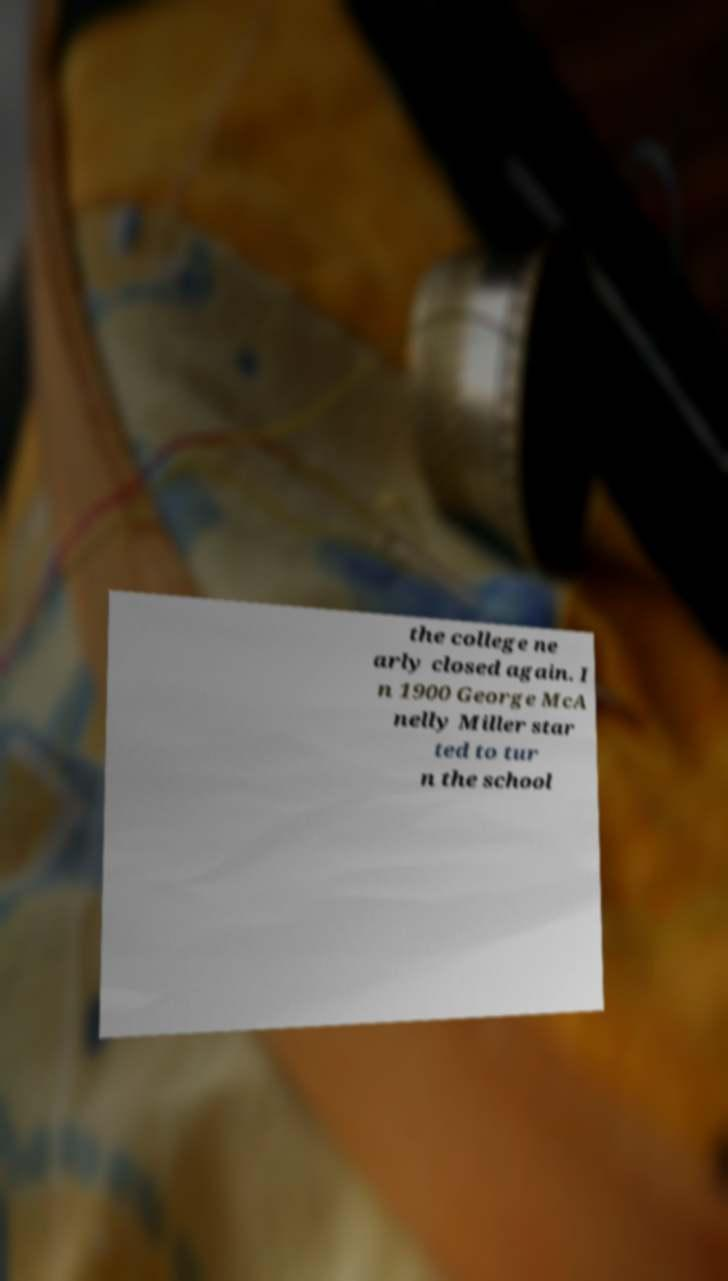There's text embedded in this image that I need extracted. Can you transcribe it verbatim? the college ne arly closed again. I n 1900 George McA nelly Miller star ted to tur n the school 